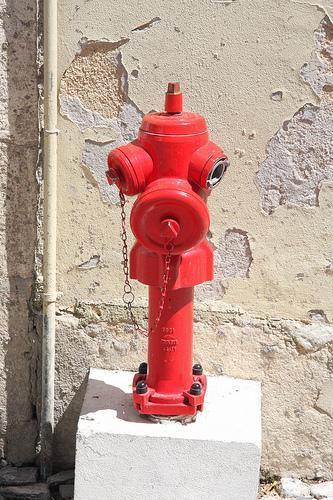How many hydrants are there?
Give a very brief answer. 1. 